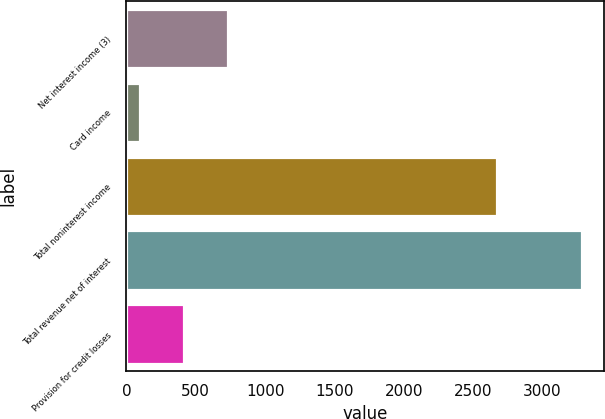Convert chart. <chart><loc_0><loc_0><loc_500><loc_500><bar_chart><fcel>Net interest income (3)<fcel>Card income<fcel>Total noninterest income<fcel>Total revenue net of interest<fcel>Provision for credit losses<nl><fcel>733.8<fcel>97<fcel>2671<fcel>3281<fcel>415.4<nl></chart> 